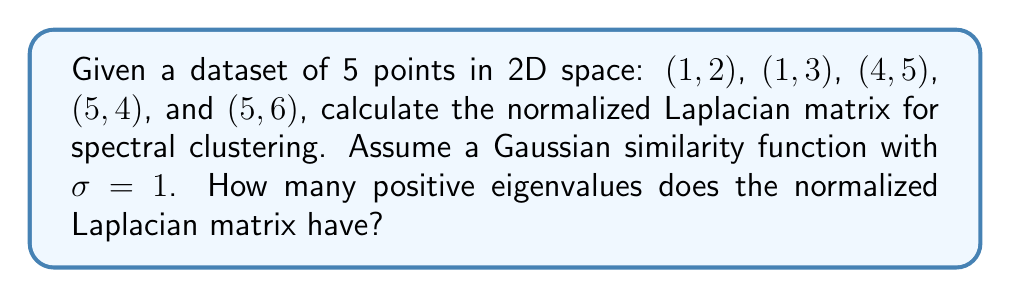Can you solve this math problem? 1. Construct the similarity matrix $W$:
   Calculate similarity $w_{ij} = e^{-\frac{||x_i - x_j||^2}{2\sigma^2}}$ for each pair of points.
   
   $$W = \begin{bmatrix}
   1 & 0.8825 & 0.0183 & 0.0111 & 0.0067 \\
   0.8825 & 1 & 0.0302 & 0.0183 & 0.0111 \\
   0.0183 & 0.0302 & 1 & 0.7165 & 0.7165 \\
   0.0111 & 0.0183 & 0.7165 & 1 & 0.7165 \\
   0.0067 & 0.0111 & 0.7165 & 0.7165 & 1
   \end{bmatrix}$$

2. Calculate the degree matrix $D$:
   Sum each row of $W$ to get the diagonal elements of $D$.
   
   $$D = \begin{bmatrix}
   1.9186 & 0 & 0 & 0 & 0 \\
   0 & 1.9421 & 0 & 0 & 0 \\
   0 & 0 & 2.4815 & 0 & 0 \\
   0 & 0 & 0 & 2.4624 & 0 \\
   0 & 0 & 0 & 0 & 2.4508
   \end{bmatrix}$$

3. Compute the normalized Laplacian $L_{sym} = I - D^{-1/2}WD^{-1/2}$:
   
   $$L_{sym} = I - \begin{bmatrix}
   0.7215 & 0.4604 & 0.0084 & 0.0052 & 0.0031 \\
   0.4604 & 0.7215 & 0.0136 & 0.0083 & 0.0050 \\
   0.0084 & 0.0136 & 0.7215 & 0.3260 & 0.3260 \\
   0.0052 & 0.0083 & 0.3260 & 0.7215 & 0.3260 \\
   0.0031 & 0.0050 & 0.3260 & 0.3260 & 0.7215
   \end{bmatrix}$$

4. Calculate the eigenvalues of $L_{sym}$:
   The eigenvalues are approximately 0, 0.2785, 0.2785, 1.4430, and 2.0000.

5. Count the number of positive eigenvalues:
   There are 4 positive eigenvalues (0.2785, 0.2785, 1.4430, and 2.0000).
Answer: 4 